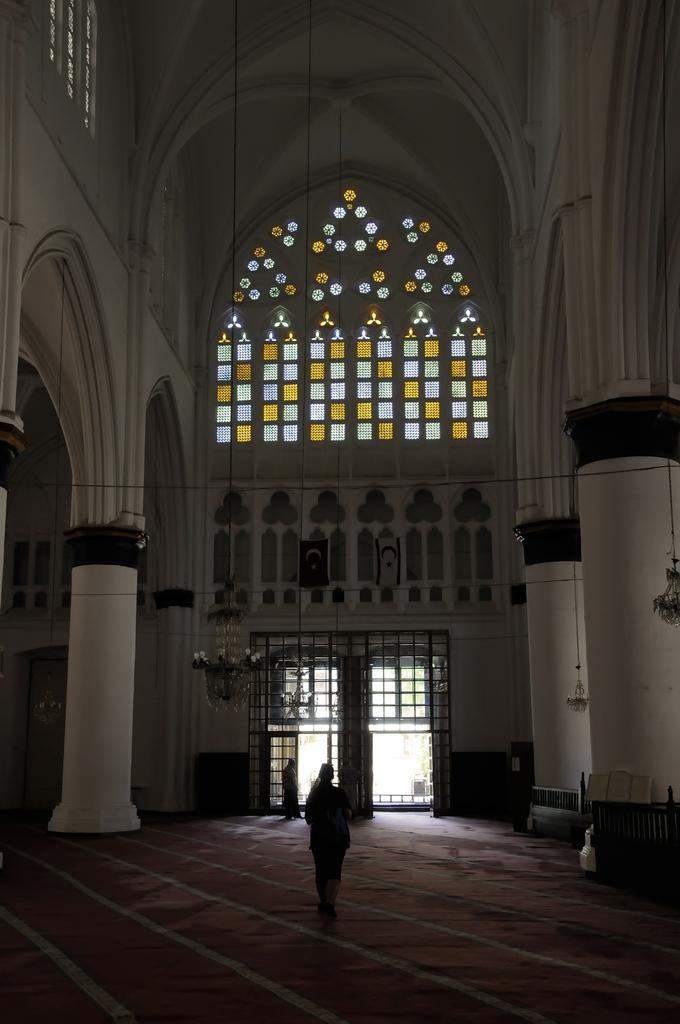In one or two sentences, can you explain what this image depicts? This is the inside view of a building. Here we can see two persons. There are pillars and a door. 